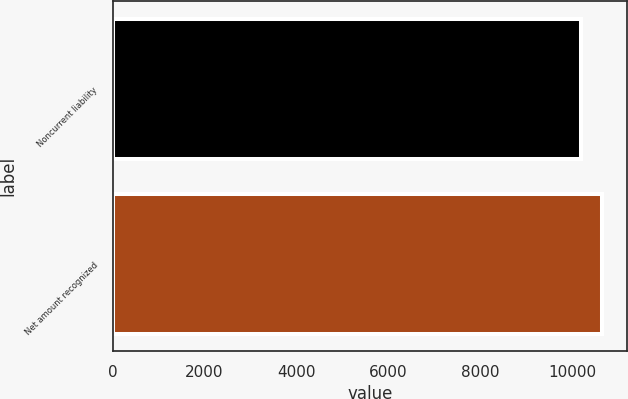<chart> <loc_0><loc_0><loc_500><loc_500><bar_chart><fcel>Noncurrent liability<fcel>Net amount recognized<nl><fcel>10203<fcel>10662<nl></chart> 